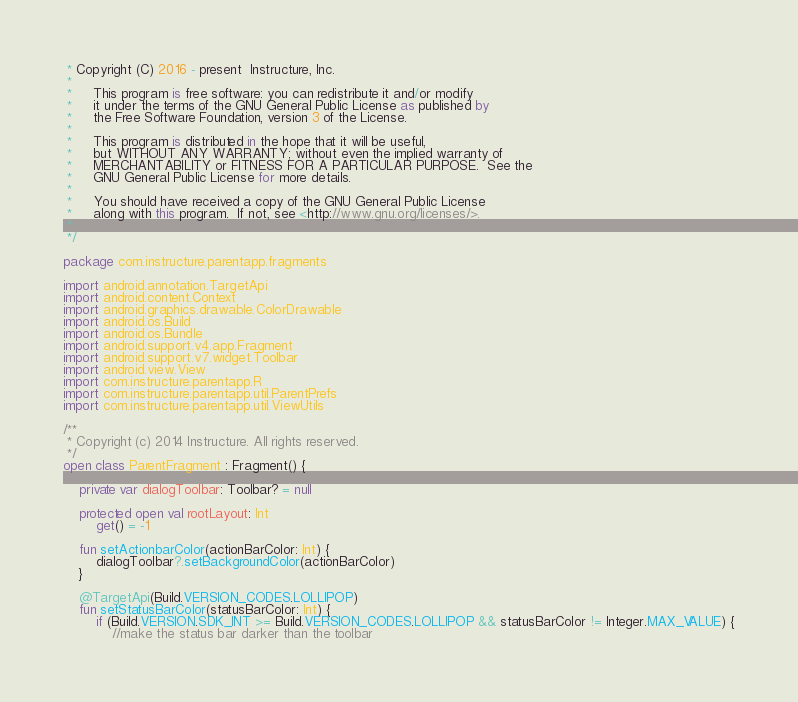<code> <loc_0><loc_0><loc_500><loc_500><_Kotlin_> * Copyright (C) 2016 - present  Instructure, Inc.
 *
 *     This program is free software: you can redistribute it and/or modify
 *     it under the terms of the GNU General Public License as published by
 *     the Free Software Foundation, version 3 of the License.
 *
 *     This program is distributed in the hope that it will be useful,
 *     but WITHOUT ANY WARRANTY; without even the implied warranty of
 *     MERCHANTABILITY or FITNESS FOR A PARTICULAR PURPOSE.  See the
 *     GNU General Public License for more details.
 *
 *     You should have received a copy of the GNU General Public License
 *     along with this program.  If not, see <http://www.gnu.org/licenses/>.
 *
 */

package com.instructure.parentapp.fragments

import android.annotation.TargetApi
import android.content.Context
import android.graphics.drawable.ColorDrawable
import android.os.Build
import android.os.Bundle
import android.support.v4.app.Fragment
import android.support.v7.widget.Toolbar
import android.view.View
import com.instructure.parentapp.R
import com.instructure.parentapp.util.ParentPrefs
import com.instructure.parentapp.util.ViewUtils

/**
 * Copyright (c) 2014 Instructure. All rights reserved.
 */
open class ParentFragment : Fragment() {

    private var dialogToolbar: Toolbar? = null

    protected open val rootLayout: Int
        get() = -1

    fun setActionbarColor(actionBarColor: Int) {
        dialogToolbar?.setBackgroundColor(actionBarColor)
    }

    @TargetApi(Build.VERSION_CODES.LOLLIPOP)
    fun setStatusBarColor(statusBarColor: Int) {
        if (Build.VERSION.SDK_INT >= Build.VERSION_CODES.LOLLIPOP && statusBarColor != Integer.MAX_VALUE) {
            //make the status bar darker than the toolbar</code> 